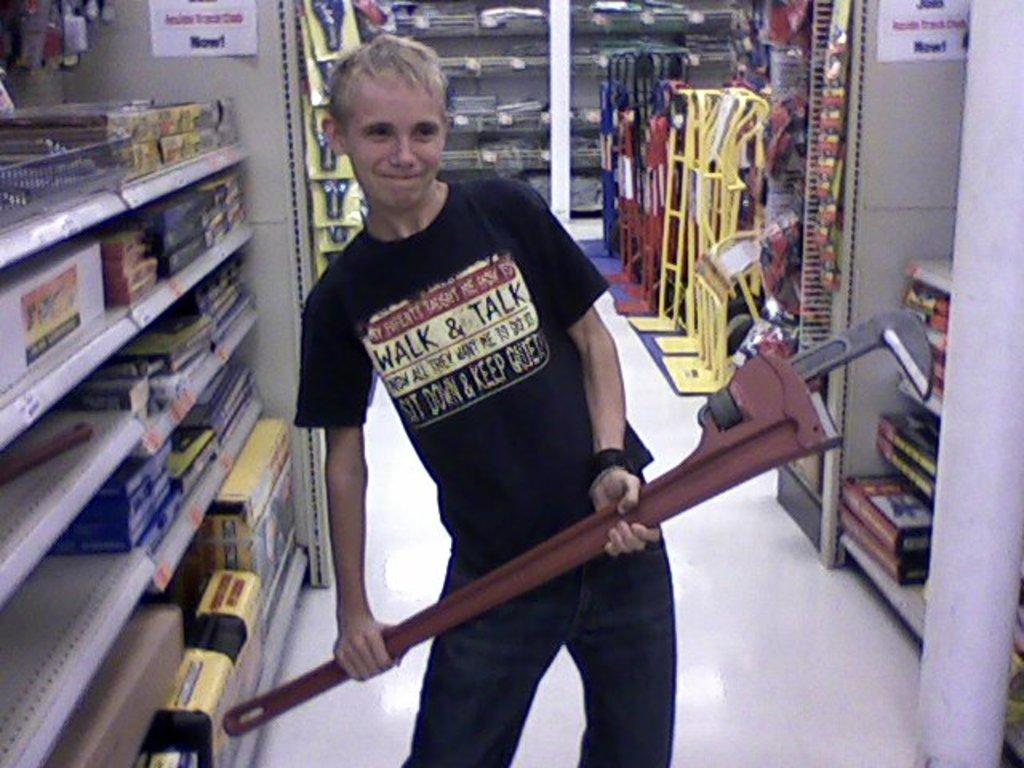Provide a one-sentence caption for the provided image. A guy with a black shirt that says "walk and talk". 